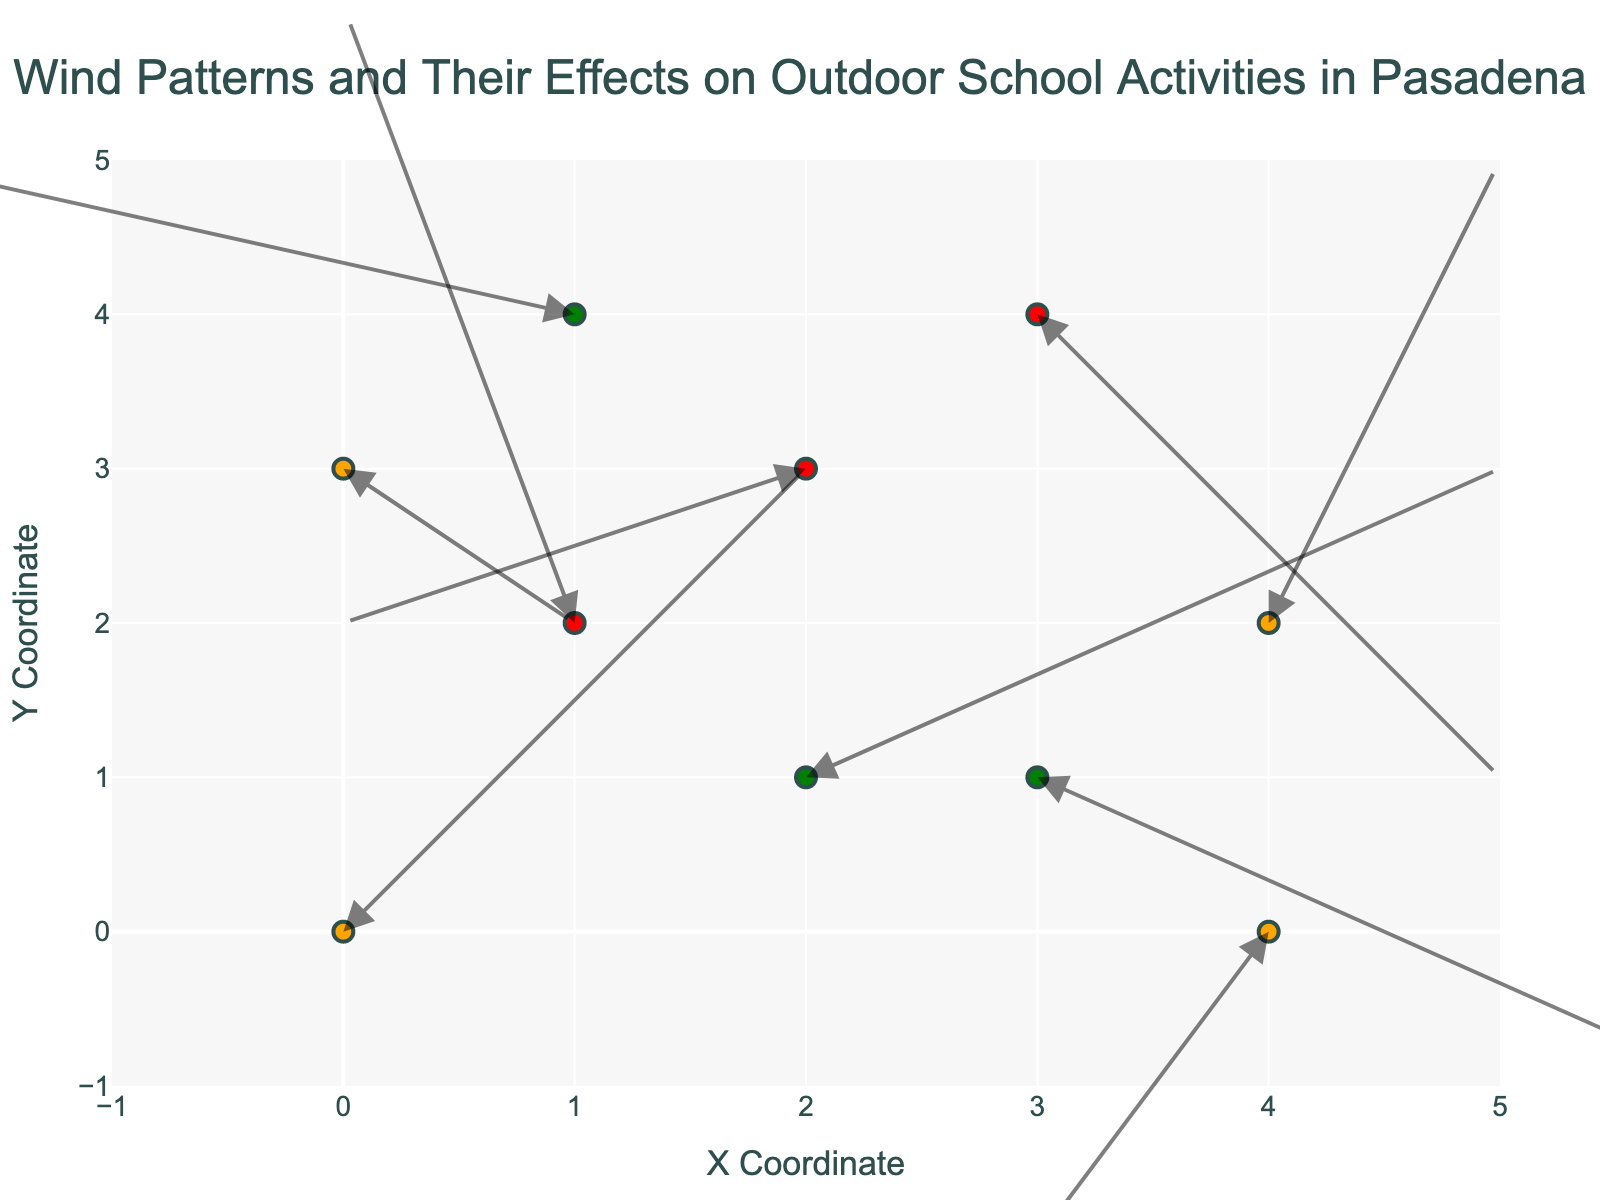What is the title of the plot? The title of the plot is found at the top of the figure. It reads: "Wind Patterns and Their Effects on Outdoor School Activities in Pasadena".
Answer: Wind Patterns and Their Effects on Outdoor School Activities in Pasadena How many data points are shown in the plot? By counting the number of markers or arrows on the plot, we can see there are 10 data points.
Answer: 10 Which activity has a high wind impact and is located at coordinates (1, 2)? By looking at the coordinates (1, 2) and the color indicating a high impact (red), we can see the activity label "Outdoor reading".
Answer: Outdoor reading Which activity experiences the strongest wind effect according to the arrow length? The strength of the wind effect is represented by the length of the arrows. Comparing all the arrows, the activity at the coordinate (1, 2) has the longest arrow, indicating the highest wind effect which is "Outdoor reading".
Answer: Outdoor reading Which activity at coordinates (3,4) has a high wind impact and what's the wind direction? By finding the coordinate (3,4) and seeing the red marker, we identify "Flag ceremony". Checking the arrow direction, it points downward to the left.
Answer: Flag ceremony, downward and left What is the average x displacement of activities with moderate wind impact? Moderate wind impacts are marked in orange. From the data: Soccer practice (u=2), Nature walk (u=1), Playground time (u=1), Outdoor lunch (u=-1). The average x displacement is calculated as (2+1+1-1)/4 = 3/4 = 0.75.
Answer: 0.75 Compare the wind effect on "Gardening club" and "Track and field". Which one shows stronger wind displacement? "Gardening club" at (1, 4) has displacement coordinates (-3, 1) and "Track and field" at (2, 3) has coordinates (-2, -1). Calculating the magnitude: Gardening club is sqrt((-3)^2 + 1^2) = sqrt(10) ≈ 3.16, Track and field is sqrt((-2)^2 + (-1)^2) = sqrt(5) ≈ 2.24.
Answer: Gardening club Are there more activities with high wind impact or low wind impact? By counting the red markers for high impact and green markers for low impact: High - 3 activities (Outdoor reading, Track and field, Flag ceremony), Low - 3 activities (Art class, Gardening club, Science experiments).
Answer: Equal number What is the direction of the wind for "Science experiments"? By looking at the coordinate (2, 1) for "Science experiments" and following the direction of the arrow, it points upward to the right.
Answer: Upward and right 